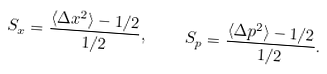Convert formula to latex. <formula><loc_0><loc_0><loc_500><loc_500>S _ { x } = \frac { \langle \Delta x ^ { 2 } \rangle - 1 / 2 } { 1 / 2 } , \quad S _ { p } = \frac { \langle \Delta p ^ { 2 } \rangle - 1 / 2 } { 1 / 2 } .</formula> 